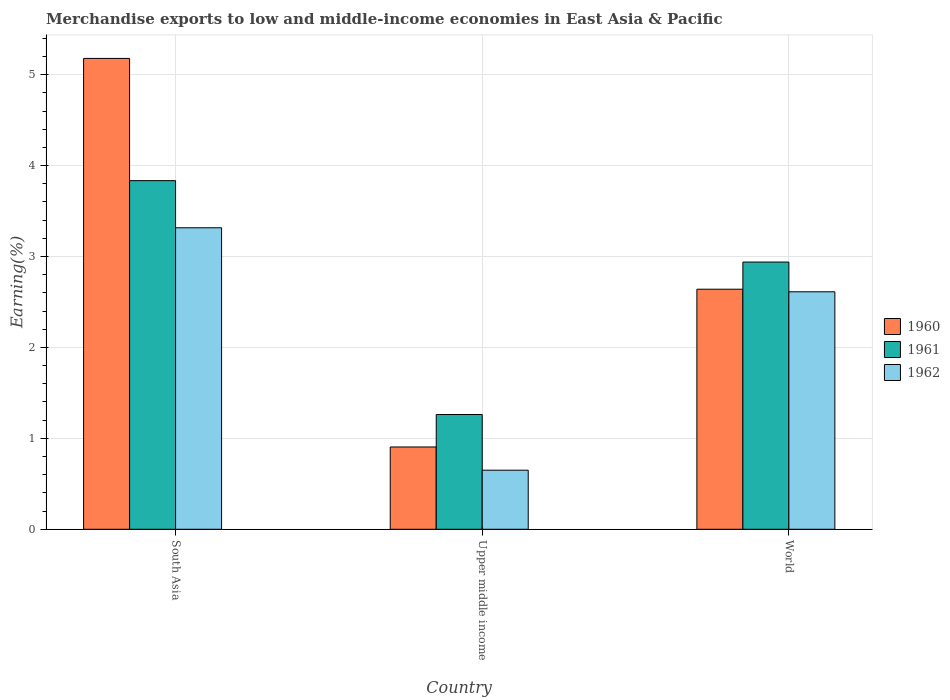How many groups of bars are there?
Make the answer very short. 3. Are the number of bars per tick equal to the number of legend labels?
Your answer should be very brief. Yes. Are the number of bars on each tick of the X-axis equal?
Give a very brief answer. Yes. How many bars are there on the 2nd tick from the right?
Your answer should be very brief. 3. What is the label of the 2nd group of bars from the left?
Make the answer very short. Upper middle income. What is the percentage of amount earned from merchandise exports in 1960 in Upper middle income?
Offer a terse response. 0.91. Across all countries, what is the maximum percentage of amount earned from merchandise exports in 1961?
Provide a short and direct response. 3.83. Across all countries, what is the minimum percentage of amount earned from merchandise exports in 1961?
Your answer should be compact. 1.26. In which country was the percentage of amount earned from merchandise exports in 1961 minimum?
Make the answer very short. Upper middle income. What is the total percentage of amount earned from merchandise exports in 1962 in the graph?
Ensure brevity in your answer.  6.58. What is the difference between the percentage of amount earned from merchandise exports in 1960 in Upper middle income and that in World?
Your answer should be compact. -1.74. What is the difference between the percentage of amount earned from merchandise exports in 1960 in South Asia and the percentage of amount earned from merchandise exports in 1961 in World?
Offer a very short reply. 2.24. What is the average percentage of amount earned from merchandise exports in 1960 per country?
Provide a succinct answer. 2.91. What is the difference between the percentage of amount earned from merchandise exports of/in 1962 and percentage of amount earned from merchandise exports of/in 1961 in South Asia?
Keep it short and to the point. -0.52. In how many countries, is the percentage of amount earned from merchandise exports in 1962 greater than 4 %?
Offer a very short reply. 0. What is the ratio of the percentage of amount earned from merchandise exports in 1962 in Upper middle income to that in World?
Keep it short and to the point. 0.25. What is the difference between the highest and the second highest percentage of amount earned from merchandise exports in 1962?
Your answer should be very brief. -1.96. What is the difference between the highest and the lowest percentage of amount earned from merchandise exports in 1961?
Give a very brief answer. 2.57. In how many countries, is the percentage of amount earned from merchandise exports in 1960 greater than the average percentage of amount earned from merchandise exports in 1960 taken over all countries?
Ensure brevity in your answer.  1. Is the sum of the percentage of amount earned from merchandise exports in 1962 in Upper middle income and World greater than the maximum percentage of amount earned from merchandise exports in 1960 across all countries?
Give a very brief answer. No. What does the 3rd bar from the left in South Asia represents?
Offer a very short reply. 1962. Are all the bars in the graph horizontal?
Keep it short and to the point. No. How many countries are there in the graph?
Offer a terse response. 3. What is the difference between two consecutive major ticks on the Y-axis?
Give a very brief answer. 1. Does the graph contain any zero values?
Provide a succinct answer. No. Does the graph contain grids?
Your answer should be very brief. Yes. How many legend labels are there?
Make the answer very short. 3. What is the title of the graph?
Make the answer very short. Merchandise exports to low and middle-income economies in East Asia & Pacific. What is the label or title of the X-axis?
Your answer should be compact. Country. What is the label or title of the Y-axis?
Keep it short and to the point. Earning(%). What is the Earning(%) of 1960 in South Asia?
Your response must be concise. 5.18. What is the Earning(%) in 1961 in South Asia?
Ensure brevity in your answer.  3.83. What is the Earning(%) in 1962 in South Asia?
Offer a terse response. 3.32. What is the Earning(%) in 1960 in Upper middle income?
Provide a short and direct response. 0.91. What is the Earning(%) in 1961 in Upper middle income?
Offer a terse response. 1.26. What is the Earning(%) of 1962 in Upper middle income?
Keep it short and to the point. 0.65. What is the Earning(%) in 1960 in World?
Offer a very short reply. 2.64. What is the Earning(%) of 1961 in World?
Give a very brief answer. 2.94. What is the Earning(%) in 1962 in World?
Give a very brief answer. 2.61. Across all countries, what is the maximum Earning(%) in 1960?
Offer a terse response. 5.18. Across all countries, what is the maximum Earning(%) of 1961?
Offer a terse response. 3.83. Across all countries, what is the maximum Earning(%) in 1962?
Your answer should be compact. 3.32. Across all countries, what is the minimum Earning(%) in 1960?
Keep it short and to the point. 0.91. Across all countries, what is the minimum Earning(%) of 1961?
Make the answer very short. 1.26. Across all countries, what is the minimum Earning(%) of 1962?
Make the answer very short. 0.65. What is the total Earning(%) of 1960 in the graph?
Offer a very short reply. 8.72. What is the total Earning(%) of 1961 in the graph?
Make the answer very short. 8.04. What is the total Earning(%) of 1962 in the graph?
Your answer should be compact. 6.58. What is the difference between the Earning(%) in 1960 in South Asia and that in Upper middle income?
Offer a terse response. 4.27. What is the difference between the Earning(%) in 1961 in South Asia and that in Upper middle income?
Provide a short and direct response. 2.57. What is the difference between the Earning(%) of 1962 in South Asia and that in Upper middle income?
Offer a very short reply. 2.67. What is the difference between the Earning(%) in 1960 in South Asia and that in World?
Give a very brief answer. 2.54. What is the difference between the Earning(%) of 1961 in South Asia and that in World?
Keep it short and to the point. 0.9. What is the difference between the Earning(%) in 1962 in South Asia and that in World?
Provide a succinct answer. 0.7. What is the difference between the Earning(%) in 1960 in Upper middle income and that in World?
Offer a terse response. -1.74. What is the difference between the Earning(%) in 1961 in Upper middle income and that in World?
Give a very brief answer. -1.68. What is the difference between the Earning(%) in 1962 in Upper middle income and that in World?
Make the answer very short. -1.96. What is the difference between the Earning(%) in 1960 in South Asia and the Earning(%) in 1961 in Upper middle income?
Provide a short and direct response. 3.92. What is the difference between the Earning(%) of 1960 in South Asia and the Earning(%) of 1962 in Upper middle income?
Keep it short and to the point. 4.53. What is the difference between the Earning(%) of 1961 in South Asia and the Earning(%) of 1962 in Upper middle income?
Give a very brief answer. 3.18. What is the difference between the Earning(%) of 1960 in South Asia and the Earning(%) of 1961 in World?
Offer a very short reply. 2.24. What is the difference between the Earning(%) of 1960 in South Asia and the Earning(%) of 1962 in World?
Keep it short and to the point. 2.57. What is the difference between the Earning(%) of 1961 in South Asia and the Earning(%) of 1962 in World?
Offer a terse response. 1.22. What is the difference between the Earning(%) of 1960 in Upper middle income and the Earning(%) of 1961 in World?
Your response must be concise. -2.03. What is the difference between the Earning(%) of 1960 in Upper middle income and the Earning(%) of 1962 in World?
Offer a very short reply. -1.71. What is the difference between the Earning(%) of 1961 in Upper middle income and the Earning(%) of 1962 in World?
Keep it short and to the point. -1.35. What is the average Earning(%) of 1960 per country?
Provide a short and direct response. 2.91. What is the average Earning(%) in 1961 per country?
Provide a short and direct response. 2.68. What is the average Earning(%) in 1962 per country?
Your answer should be very brief. 2.19. What is the difference between the Earning(%) of 1960 and Earning(%) of 1961 in South Asia?
Your response must be concise. 1.34. What is the difference between the Earning(%) in 1960 and Earning(%) in 1962 in South Asia?
Make the answer very short. 1.86. What is the difference between the Earning(%) in 1961 and Earning(%) in 1962 in South Asia?
Provide a short and direct response. 0.52. What is the difference between the Earning(%) of 1960 and Earning(%) of 1961 in Upper middle income?
Offer a very short reply. -0.36. What is the difference between the Earning(%) in 1960 and Earning(%) in 1962 in Upper middle income?
Offer a terse response. 0.26. What is the difference between the Earning(%) in 1961 and Earning(%) in 1962 in Upper middle income?
Ensure brevity in your answer.  0.61. What is the difference between the Earning(%) in 1960 and Earning(%) in 1961 in World?
Keep it short and to the point. -0.3. What is the difference between the Earning(%) of 1960 and Earning(%) of 1962 in World?
Your answer should be compact. 0.03. What is the difference between the Earning(%) of 1961 and Earning(%) of 1962 in World?
Keep it short and to the point. 0.33. What is the ratio of the Earning(%) of 1960 in South Asia to that in Upper middle income?
Give a very brief answer. 5.72. What is the ratio of the Earning(%) in 1961 in South Asia to that in Upper middle income?
Provide a short and direct response. 3.04. What is the ratio of the Earning(%) of 1962 in South Asia to that in Upper middle income?
Your response must be concise. 5.1. What is the ratio of the Earning(%) in 1960 in South Asia to that in World?
Provide a short and direct response. 1.96. What is the ratio of the Earning(%) in 1961 in South Asia to that in World?
Ensure brevity in your answer.  1.3. What is the ratio of the Earning(%) of 1962 in South Asia to that in World?
Give a very brief answer. 1.27. What is the ratio of the Earning(%) of 1960 in Upper middle income to that in World?
Your answer should be compact. 0.34. What is the ratio of the Earning(%) of 1961 in Upper middle income to that in World?
Make the answer very short. 0.43. What is the ratio of the Earning(%) of 1962 in Upper middle income to that in World?
Offer a terse response. 0.25. What is the difference between the highest and the second highest Earning(%) in 1960?
Provide a short and direct response. 2.54. What is the difference between the highest and the second highest Earning(%) of 1961?
Keep it short and to the point. 0.9. What is the difference between the highest and the second highest Earning(%) in 1962?
Keep it short and to the point. 0.7. What is the difference between the highest and the lowest Earning(%) in 1960?
Your answer should be compact. 4.27. What is the difference between the highest and the lowest Earning(%) in 1961?
Your response must be concise. 2.57. What is the difference between the highest and the lowest Earning(%) of 1962?
Your answer should be compact. 2.67. 